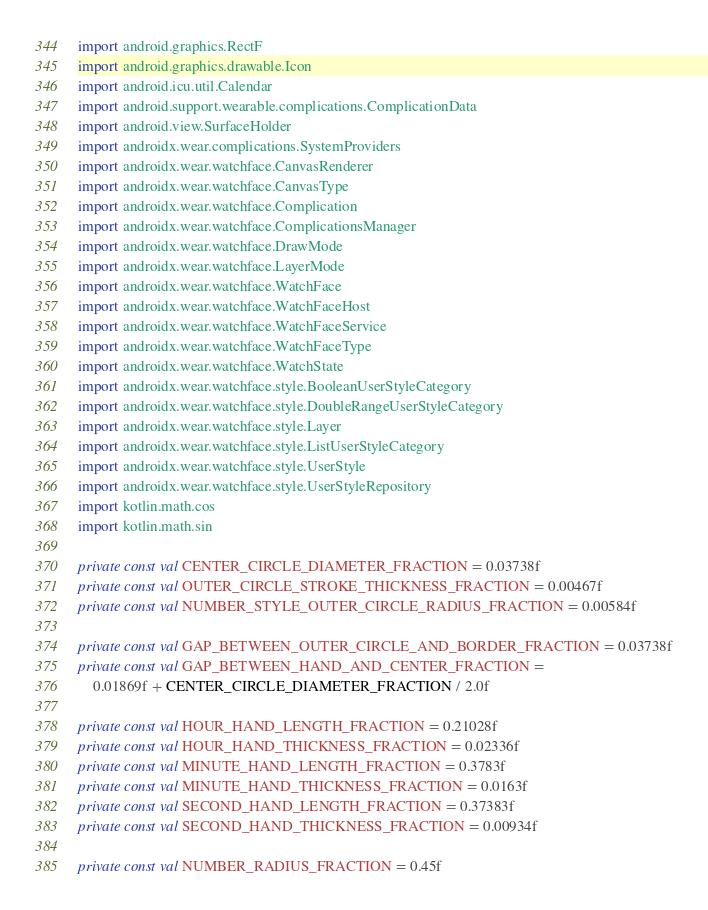<code> <loc_0><loc_0><loc_500><loc_500><_Kotlin_>import android.graphics.RectF
import android.graphics.drawable.Icon
import android.icu.util.Calendar
import android.support.wearable.complications.ComplicationData
import android.view.SurfaceHolder
import androidx.wear.complications.SystemProviders
import androidx.wear.watchface.CanvasRenderer
import androidx.wear.watchface.CanvasType
import androidx.wear.watchface.Complication
import androidx.wear.watchface.ComplicationsManager
import androidx.wear.watchface.DrawMode
import androidx.wear.watchface.LayerMode
import androidx.wear.watchface.WatchFace
import androidx.wear.watchface.WatchFaceHost
import androidx.wear.watchface.WatchFaceService
import androidx.wear.watchface.WatchFaceType
import androidx.wear.watchface.WatchState
import androidx.wear.watchface.style.BooleanUserStyleCategory
import androidx.wear.watchface.style.DoubleRangeUserStyleCategory
import androidx.wear.watchface.style.Layer
import androidx.wear.watchface.style.ListUserStyleCategory
import androidx.wear.watchface.style.UserStyle
import androidx.wear.watchface.style.UserStyleRepository
import kotlin.math.cos
import kotlin.math.sin

private const val CENTER_CIRCLE_DIAMETER_FRACTION = 0.03738f
private const val OUTER_CIRCLE_STROKE_THICKNESS_FRACTION = 0.00467f
private const val NUMBER_STYLE_OUTER_CIRCLE_RADIUS_FRACTION = 0.00584f

private const val GAP_BETWEEN_OUTER_CIRCLE_AND_BORDER_FRACTION = 0.03738f
private const val GAP_BETWEEN_HAND_AND_CENTER_FRACTION =
    0.01869f + CENTER_CIRCLE_DIAMETER_FRACTION / 2.0f

private const val HOUR_HAND_LENGTH_FRACTION = 0.21028f
private const val HOUR_HAND_THICKNESS_FRACTION = 0.02336f
private const val MINUTE_HAND_LENGTH_FRACTION = 0.3783f
private const val MINUTE_HAND_THICKNESS_FRACTION = 0.0163f
private const val SECOND_HAND_LENGTH_FRACTION = 0.37383f
private const val SECOND_HAND_THICKNESS_FRACTION = 0.00934f

private const val NUMBER_RADIUS_FRACTION = 0.45f
</code> 